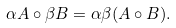Convert formula to latex. <formula><loc_0><loc_0><loc_500><loc_500>\alpha A \circ \beta B = \alpha \beta ( A \circ B ) .</formula> 